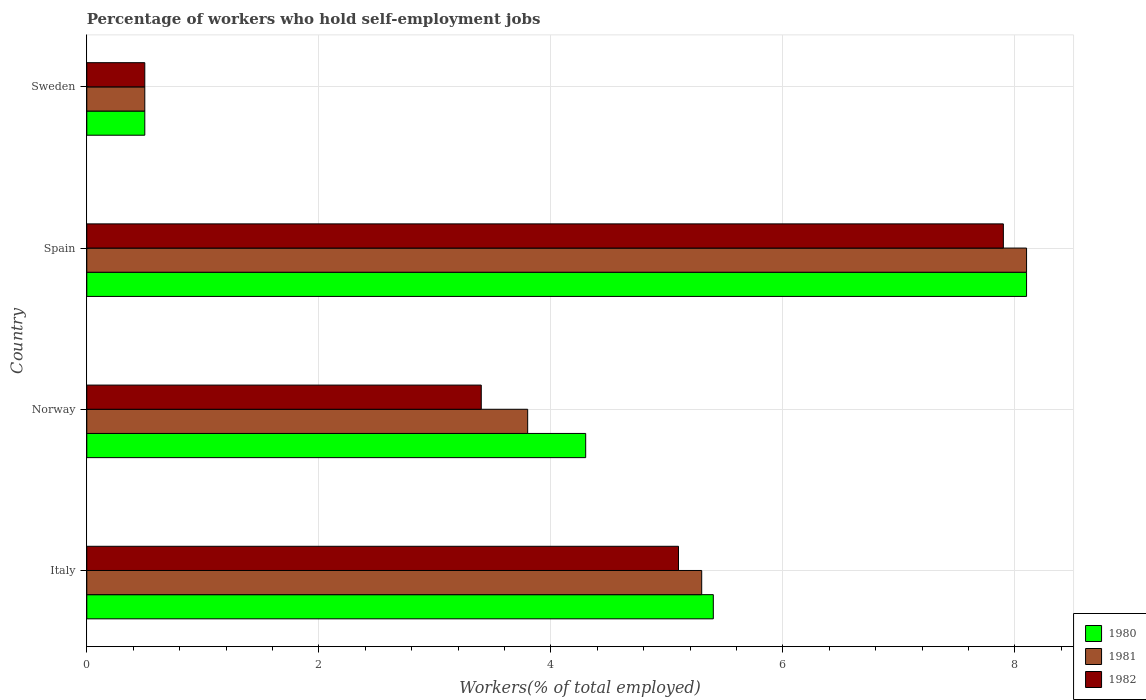How many different coloured bars are there?
Ensure brevity in your answer.  3. How many groups of bars are there?
Ensure brevity in your answer.  4. Are the number of bars on each tick of the Y-axis equal?
Make the answer very short. Yes. What is the label of the 1st group of bars from the top?
Your answer should be very brief. Sweden. In how many cases, is the number of bars for a given country not equal to the number of legend labels?
Your answer should be compact. 0. What is the percentage of self-employed workers in 1982 in Italy?
Ensure brevity in your answer.  5.1. Across all countries, what is the maximum percentage of self-employed workers in 1982?
Give a very brief answer. 7.9. What is the total percentage of self-employed workers in 1980 in the graph?
Give a very brief answer. 18.3. What is the difference between the percentage of self-employed workers in 1981 in Italy and that in Spain?
Provide a succinct answer. -2.8. What is the difference between the percentage of self-employed workers in 1980 in Spain and the percentage of self-employed workers in 1982 in Sweden?
Your response must be concise. 7.6. What is the average percentage of self-employed workers in 1981 per country?
Make the answer very short. 4.43. What is the difference between the percentage of self-employed workers in 1982 and percentage of self-employed workers in 1981 in Italy?
Offer a very short reply. -0.2. What is the ratio of the percentage of self-employed workers in 1981 in Spain to that in Sweden?
Your answer should be very brief. 16.2. What is the difference between the highest and the second highest percentage of self-employed workers in 1981?
Your answer should be very brief. 2.8. What is the difference between the highest and the lowest percentage of self-employed workers in 1981?
Provide a short and direct response. 7.6. In how many countries, is the percentage of self-employed workers in 1980 greater than the average percentage of self-employed workers in 1980 taken over all countries?
Your answer should be very brief. 2. Is the sum of the percentage of self-employed workers in 1980 in Italy and Sweden greater than the maximum percentage of self-employed workers in 1982 across all countries?
Your answer should be compact. No. How many countries are there in the graph?
Your response must be concise. 4. Are the values on the major ticks of X-axis written in scientific E-notation?
Your answer should be very brief. No. Does the graph contain any zero values?
Make the answer very short. No. Does the graph contain grids?
Your response must be concise. Yes. How are the legend labels stacked?
Make the answer very short. Vertical. What is the title of the graph?
Provide a succinct answer. Percentage of workers who hold self-employment jobs. What is the label or title of the X-axis?
Offer a very short reply. Workers(% of total employed). What is the label or title of the Y-axis?
Offer a very short reply. Country. What is the Workers(% of total employed) in 1980 in Italy?
Your answer should be compact. 5.4. What is the Workers(% of total employed) of 1981 in Italy?
Offer a very short reply. 5.3. What is the Workers(% of total employed) of 1982 in Italy?
Your response must be concise. 5.1. What is the Workers(% of total employed) in 1980 in Norway?
Offer a very short reply. 4.3. What is the Workers(% of total employed) of 1981 in Norway?
Provide a succinct answer. 3.8. What is the Workers(% of total employed) of 1982 in Norway?
Give a very brief answer. 3.4. What is the Workers(% of total employed) of 1980 in Spain?
Keep it short and to the point. 8.1. What is the Workers(% of total employed) in 1981 in Spain?
Your answer should be compact. 8.1. What is the Workers(% of total employed) in 1982 in Spain?
Give a very brief answer. 7.9. What is the Workers(% of total employed) of 1980 in Sweden?
Your answer should be very brief. 0.5. What is the Workers(% of total employed) of 1981 in Sweden?
Make the answer very short. 0.5. What is the Workers(% of total employed) in 1982 in Sweden?
Your response must be concise. 0.5. Across all countries, what is the maximum Workers(% of total employed) in 1980?
Provide a succinct answer. 8.1. Across all countries, what is the maximum Workers(% of total employed) of 1981?
Offer a terse response. 8.1. Across all countries, what is the maximum Workers(% of total employed) in 1982?
Offer a terse response. 7.9. Across all countries, what is the minimum Workers(% of total employed) of 1980?
Your answer should be compact. 0.5. Across all countries, what is the minimum Workers(% of total employed) in 1981?
Provide a short and direct response. 0.5. What is the difference between the Workers(% of total employed) in 1981 in Italy and that in Norway?
Offer a terse response. 1.5. What is the difference between the Workers(% of total employed) in 1980 in Italy and that in Spain?
Keep it short and to the point. -2.7. What is the difference between the Workers(% of total employed) of 1981 in Italy and that in Spain?
Make the answer very short. -2.8. What is the difference between the Workers(% of total employed) in 1982 in Italy and that in Spain?
Offer a terse response. -2.8. What is the difference between the Workers(% of total employed) of 1980 in Norway and that in Spain?
Offer a very short reply. -3.8. What is the difference between the Workers(% of total employed) of 1981 in Norway and that in Spain?
Your response must be concise. -4.3. What is the difference between the Workers(% of total employed) in 1982 in Norway and that in Spain?
Your response must be concise. -4.5. What is the difference between the Workers(% of total employed) of 1982 in Norway and that in Sweden?
Provide a succinct answer. 2.9. What is the difference between the Workers(% of total employed) in 1980 in Spain and that in Sweden?
Offer a terse response. 7.6. What is the difference between the Workers(% of total employed) in 1982 in Spain and that in Sweden?
Your answer should be compact. 7.4. What is the difference between the Workers(% of total employed) of 1980 in Italy and the Workers(% of total employed) of 1982 in Norway?
Your answer should be compact. 2. What is the difference between the Workers(% of total employed) in 1981 in Italy and the Workers(% of total employed) in 1982 in Norway?
Offer a terse response. 1.9. What is the difference between the Workers(% of total employed) in 1980 in Italy and the Workers(% of total employed) in 1982 in Spain?
Give a very brief answer. -2.5. What is the difference between the Workers(% of total employed) of 1981 in Italy and the Workers(% of total employed) of 1982 in Spain?
Ensure brevity in your answer.  -2.6. What is the difference between the Workers(% of total employed) in 1980 in Norway and the Workers(% of total employed) in 1982 in Spain?
Provide a short and direct response. -3.6. What is the difference between the Workers(% of total employed) in 1980 in Norway and the Workers(% of total employed) in 1981 in Sweden?
Make the answer very short. 3.8. What is the difference between the Workers(% of total employed) in 1980 in Norway and the Workers(% of total employed) in 1982 in Sweden?
Give a very brief answer. 3.8. What is the difference between the Workers(% of total employed) in 1980 in Spain and the Workers(% of total employed) in 1982 in Sweden?
Make the answer very short. 7.6. What is the average Workers(% of total employed) of 1980 per country?
Offer a very short reply. 4.58. What is the average Workers(% of total employed) in 1981 per country?
Provide a succinct answer. 4.42. What is the average Workers(% of total employed) in 1982 per country?
Your response must be concise. 4.22. What is the difference between the Workers(% of total employed) of 1980 and Workers(% of total employed) of 1981 in Italy?
Provide a short and direct response. 0.1. What is the difference between the Workers(% of total employed) in 1980 and Workers(% of total employed) in 1981 in Spain?
Your answer should be compact. 0. What is the difference between the Workers(% of total employed) in 1980 and Workers(% of total employed) in 1982 in Spain?
Your answer should be very brief. 0.2. What is the difference between the Workers(% of total employed) of 1981 and Workers(% of total employed) of 1982 in Spain?
Provide a short and direct response. 0.2. What is the difference between the Workers(% of total employed) in 1980 and Workers(% of total employed) in 1981 in Sweden?
Give a very brief answer. 0. What is the difference between the Workers(% of total employed) in 1981 and Workers(% of total employed) in 1982 in Sweden?
Offer a very short reply. 0. What is the ratio of the Workers(% of total employed) in 1980 in Italy to that in Norway?
Ensure brevity in your answer.  1.26. What is the ratio of the Workers(% of total employed) of 1981 in Italy to that in Norway?
Provide a short and direct response. 1.39. What is the ratio of the Workers(% of total employed) of 1981 in Italy to that in Spain?
Offer a very short reply. 0.65. What is the ratio of the Workers(% of total employed) of 1982 in Italy to that in Spain?
Provide a succinct answer. 0.65. What is the ratio of the Workers(% of total employed) of 1980 in Italy to that in Sweden?
Your answer should be compact. 10.8. What is the ratio of the Workers(% of total employed) of 1981 in Italy to that in Sweden?
Your response must be concise. 10.6. What is the ratio of the Workers(% of total employed) of 1980 in Norway to that in Spain?
Your response must be concise. 0.53. What is the ratio of the Workers(% of total employed) of 1981 in Norway to that in Spain?
Give a very brief answer. 0.47. What is the ratio of the Workers(% of total employed) of 1982 in Norway to that in Spain?
Make the answer very short. 0.43. What is the ratio of the Workers(% of total employed) in 1981 in Norway to that in Sweden?
Give a very brief answer. 7.6. What is the ratio of the Workers(% of total employed) of 1982 in Norway to that in Sweden?
Ensure brevity in your answer.  6.8. What is the ratio of the Workers(% of total employed) in 1980 in Spain to that in Sweden?
Provide a succinct answer. 16.2. What is the difference between the highest and the second highest Workers(% of total employed) of 1981?
Your answer should be compact. 2.8. What is the difference between the highest and the second highest Workers(% of total employed) of 1982?
Your response must be concise. 2.8. What is the difference between the highest and the lowest Workers(% of total employed) in 1980?
Make the answer very short. 7.6. What is the difference between the highest and the lowest Workers(% of total employed) in 1982?
Give a very brief answer. 7.4. 